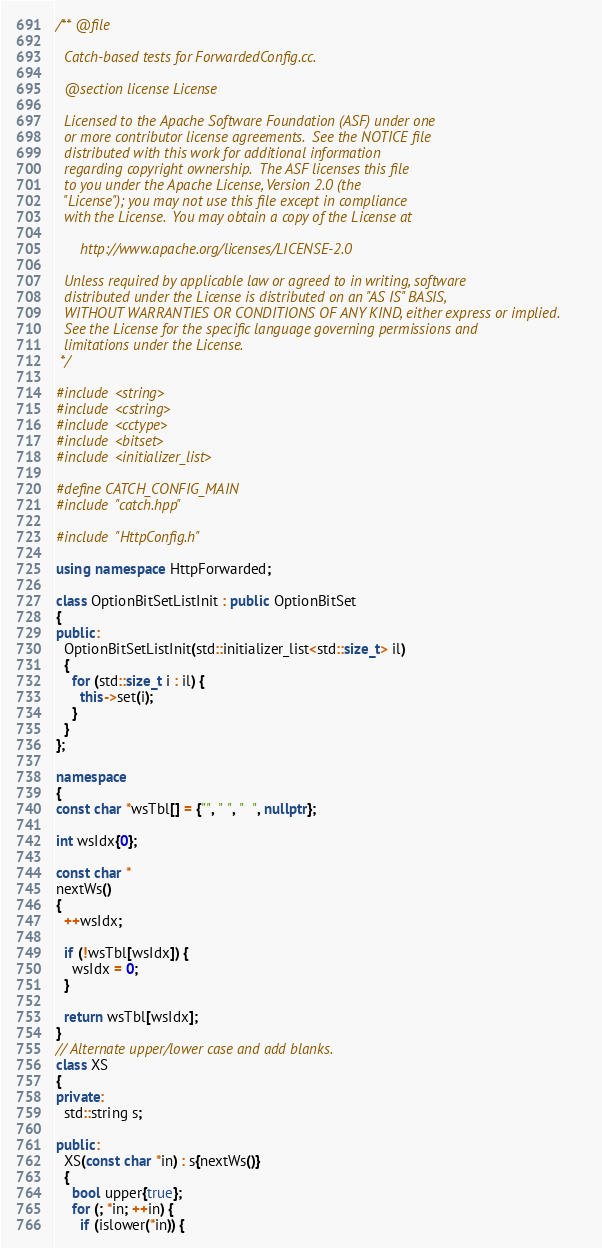<code> <loc_0><loc_0><loc_500><loc_500><_C++_>/** @file

  Catch-based tests for ForwardedConfig.cc.

  @section license License

  Licensed to the Apache Software Foundation (ASF) under one
  or more contributor license agreements.  See the NOTICE file
  distributed with this work for additional information
  regarding copyright ownership.  The ASF licenses this file
  to you under the Apache License, Version 2.0 (the
  "License"); you may not use this file except in compliance
  with the License.  You may obtain a copy of the License at

      http://www.apache.org/licenses/LICENSE-2.0

  Unless required by applicable law or agreed to in writing, software
  distributed under the License is distributed on an "AS IS" BASIS,
  WITHOUT WARRANTIES OR CONDITIONS OF ANY KIND, either express or implied.
  See the License for the specific language governing permissions and
  limitations under the License.
 */

#include <string>
#include <cstring>
#include <cctype>
#include <bitset>
#include <initializer_list>

#define CATCH_CONFIG_MAIN
#include "catch.hpp"

#include "HttpConfig.h"

using namespace HttpForwarded;

class OptionBitSetListInit : public OptionBitSet
{
public:
  OptionBitSetListInit(std::initializer_list<std::size_t> il)
  {
    for (std::size_t i : il) {
      this->set(i);
    }
  }
};

namespace
{
const char *wsTbl[] = {"", " ", "  ", nullptr};

int wsIdx{0};

const char *
nextWs()
{
  ++wsIdx;

  if (!wsTbl[wsIdx]) {
    wsIdx = 0;
  }

  return wsTbl[wsIdx];
}
// Alternate upper/lower case and add blanks.
class XS
{
private:
  std::string s;

public:
  XS(const char *in) : s{nextWs()}
  {
    bool upper{true};
    for (; *in; ++in) {
      if (islower(*in)) {</code> 